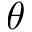Convert formula to latex. <formula><loc_0><loc_0><loc_500><loc_500>\theta</formula> 